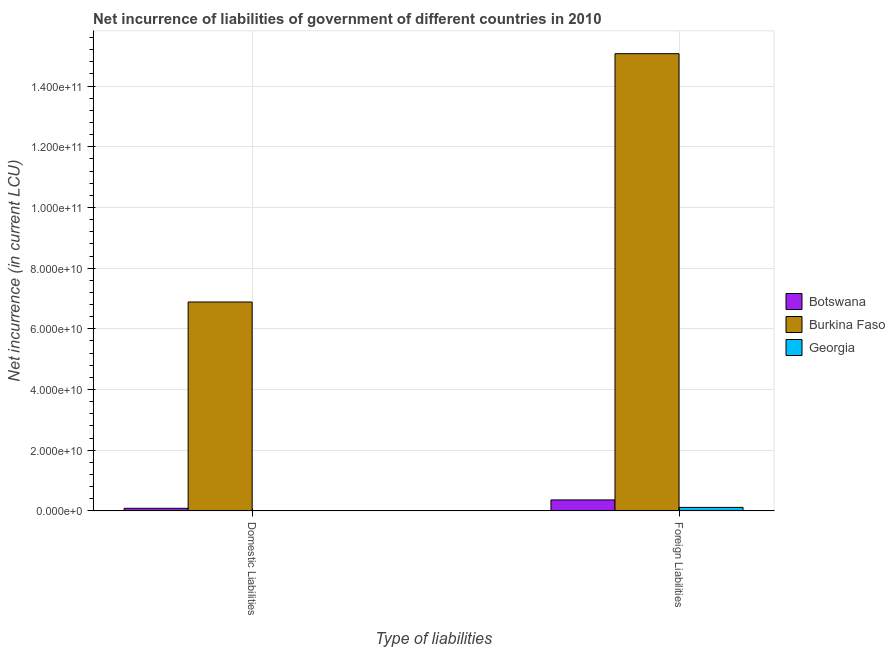How many groups of bars are there?
Your answer should be very brief. 2. Are the number of bars per tick equal to the number of legend labels?
Offer a terse response. Yes. How many bars are there on the 2nd tick from the left?
Make the answer very short. 3. What is the label of the 2nd group of bars from the left?
Offer a very short reply. Foreign Liabilities. What is the net incurrence of foreign liabilities in Burkina Faso?
Ensure brevity in your answer.  1.51e+11. Across all countries, what is the maximum net incurrence of foreign liabilities?
Offer a very short reply. 1.51e+11. Across all countries, what is the minimum net incurrence of domestic liabilities?
Ensure brevity in your answer.  1.24e+08. In which country was the net incurrence of foreign liabilities maximum?
Your answer should be compact. Burkina Faso. In which country was the net incurrence of foreign liabilities minimum?
Offer a terse response. Georgia. What is the total net incurrence of foreign liabilities in the graph?
Offer a terse response. 1.55e+11. What is the difference between the net incurrence of foreign liabilities in Georgia and that in Botswana?
Make the answer very short. -2.46e+09. What is the difference between the net incurrence of foreign liabilities in Botswana and the net incurrence of domestic liabilities in Burkina Faso?
Offer a very short reply. -6.52e+1. What is the average net incurrence of domestic liabilities per country?
Your response must be concise. 2.33e+1. What is the difference between the net incurrence of domestic liabilities and net incurrence of foreign liabilities in Burkina Faso?
Make the answer very short. -8.18e+1. In how many countries, is the net incurrence of foreign liabilities greater than 28000000000 LCU?
Provide a short and direct response. 1. What is the ratio of the net incurrence of domestic liabilities in Botswana to that in Burkina Faso?
Your answer should be compact. 0.01. In how many countries, is the net incurrence of foreign liabilities greater than the average net incurrence of foreign liabilities taken over all countries?
Make the answer very short. 1. What does the 2nd bar from the left in Foreign Liabilities represents?
Offer a very short reply. Burkina Faso. What does the 1st bar from the right in Domestic Liabilities represents?
Your answer should be compact. Georgia. What is the difference between two consecutive major ticks on the Y-axis?
Your answer should be compact. 2.00e+1. Does the graph contain any zero values?
Provide a succinct answer. No. Does the graph contain grids?
Offer a terse response. Yes. How are the legend labels stacked?
Provide a succinct answer. Vertical. What is the title of the graph?
Offer a terse response. Net incurrence of liabilities of government of different countries in 2010. Does "Albania" appear as one of the legend labels in the graph?
Provide a short and direct response. No. What is the label or title of the X-axis?
Keep it short and to the point. Type of liabilities. What is the label or title of the Y-axis?
Make the answer very short. Net incurrence (in current LCU). What is the Net incurrence (in current LCU) of Botswana in Domestic Liabilities?
Your answer should be compact. 8.48e+08. What is the Net incurrence (in current LCU) in Burkina Faso in Domestic Liabilities?
Keep it short and to the point. 6.88e+1. What is the Net incurrence (in current LCU) in Georgia in Domestic Liabilities?
Offer a very short reply. 1.24e+08. What is the Net incurrence (in current LCU) in Botswana in Foreign Liabilities?
Your response must be concise. 3.61e+09. What is the Net incurrence (in current LCU) of Burkina Faso in Foreign Liabilities?
Provide a short and direct response. 1.51e+11. What is the Net incurrence (in current LCU) of Georgia in Foreign Liabilities?
Ensure brevity in your answer.  1.15e+09. Across all Type of liabilities, what is the maximum Net incurrence (in current LCU) in Botswana?
Make the answer very short. 3.61e+09. Across all Type of liabilities, what is the maximum Net incurrence (in current LCU) in Burkina Faso?
Your answer should be compact. 1.51e+11. Across all Type of liabilities, what is the maximum Net incurrence (in current LCU) in Georgia?
Your answer should be compact. 1.15e+09. Across all Type of liabilities, what is the minimum Net incurrence (in current LCU) in Botswana?
Your answer should be very brief. 8.48e+08. Across all Type of liabilities, what is the minimum Net incurrence (in current LCU) of Burkina Faso?
Ensure brevity in your answer.  6.88e+1. Across all Type of liabilities, what is the minimum Net incurrence (in current LCU) in Georgia?
Offer a terse response. 1.24e+08. What is the total Net incurrence (in current LCU) of Botswana in the graph?
Give a very brief answer. 4.46e+09. What is the total Net incurrence (in current LCU) of Burkina Faso in the graph?
Give a very brief answer. 2.20e+11. What is the total Net incurrence (in current LCU) in Georgia in the graph?
Make the answer very short. 1.28e+09. What is the difference between the Net incurrence (in current LCU) in Botswana in Domestic Liabilities and that in Foreign Liabilities?
Offer a very short reply. -2.77e+09. What is the difference between the Net incurrence (in current LCU) of Burkina Faso in Domestic Liabilities and that in Foreign Liabilities?
Your answer should be compact. -8.18e+1. What is the difference between the Net incurrence (in current LCU) of Georgia in Domestic Liabilities and that in Foreign Liabilities?
Ensure brevity in your answer.  -1.03e+09. What is the difference between the Net incurrence (in current LCU) of Botswana in Domestic Liabilities and the Net incurrence (in current LCU) of Burkina Faso in Foreign Liabilities?
Give a very brief answer. -1.50e+11. What is the difference between the Net incurrence (in current LCU) in Botswana in Domestic Liabilities and the Net incurrence (in current LCU) in Georgia in Foreign Liabilities?
Your answer should be very brief. -3.04e+08. What is the difference between the Net incurrence (in current LCU) of Burkina Faso in Domestic Liabilities and the Net incurrence (in current LCU) of Georgia in Foreign Liabilities?
Provide a short and direct response. 6.77e+1. What is the average Net incurrence (in current LCU) of Botswana per Type of liabilities?
Your answer should be very brief. 2.23e+09. What is the average Net incurrence (in current LCU) in Burkina Faso per Type of liabilities?
Keep it short and to the point. 1.10e+11. What is the average Net incurrence (in current LCU) of Georgia per Type of liabilities?
Ensure brevity in your answer.  6.38e+08. What is the difference between the Net incurrence (in current LCU) in Botswana and Net incurrence (in current LCU) in Burkina Faso in Domestic Liabilities?
Provide a short and direct response. -6.80e+1. What is the difference between the Net incurrence (in current LCU) in Botswana and Net incurrence (in current LCU) in Georgia in Domestic Liabilities?
Offer a terse response. 7.25e+08. What is the difference between the Net incurrence (in current LCU) in Burkina Faso and Net incurrence (in current LCU) in Georgia in Domestic Liabilities?
Your response must be concise. 6.87e+1. What is the difference between the Net incurrence (in current LCU) in Botswana and Net incurrence (in current LCU) in Burkina Faso in Foreign Liabilities?
Give a very brief answer. -1.47e+11. What is the difference between the Net incurrence (in current LCU) of Botswana and Net incurrence (in current LCU) of Georgia in Foreign Liabilities?
Your answer should be compact. 2.46e+09. What is the difference between the Net incurrence (in current LCU) of Burkina Faso and Net incurrence (in current LCU) of Georgia in Foreign Liabilities?
Your answer should be very brief. 1.50e+11. What is the ratio of the Net incurrence (in current LCU) in Botswana in Domestic Liabilities to that in Foreign Liabilities?
Keep it short and to the point. 0.23. What is the ratio of the Net incurrence (in current LCU) of Burkina Faso in Domestic Liabilities to that in Foreign Liabilities?
Offer a terse response. 0.46. What is the ratio of the Net incurrence (in current LCU) of Georgia in Domestic Liabilities to that in Foreign Liabilities?
Make the answer very short. 0.11. What is the difference between the highest and the second highest Net incurrence (in current LCU) in Botswana?
Ensure brevity in your answer.  2.77e+09. What is the difference between the highest and the second highest Net incurrence (in current LCU) of Burkina Faso?
Provide a short and direct response. 8.18e+1. What is the difference between the highest and the second highest Net incurrence (in current LCU) of Georgia?
Your answer should be very brief. 1.03e+09. What is the difference between the highest and the lowest Net incurrence (in current LCU) in Botswana?
Your answer should be compact. 2.77e+09. What is the difference between the highest and the lowest Net incurrence (in current LCU) in Burkina Faso?
Offer a terse response. 8.18e+1. What is the difference between the highest and the lowest Net incurrence (in current LCU) of Georgia?
Keep it short and to the point. 1.03e+09. 